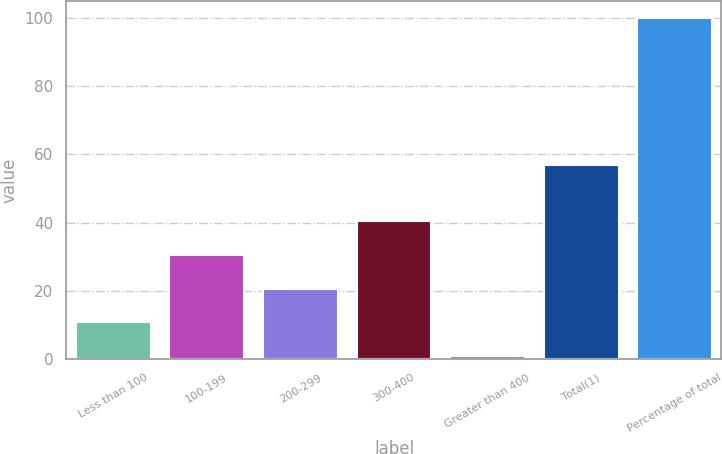<chart> <loc_0><loc_0><loc_500><loc_500><bar_chart><fcel>Less than 100<fcel>100-199<fcel>200-299<fcel>300-400<fcel>Greater than 400<fcel>Total(1)<fcel>Percentage of total<nl><fcel>10.81<fcel>30.63<fcel>20.72<fcel>40.54<fcel>0.9<fcel>56.9<fcel>100<nl></chart> 